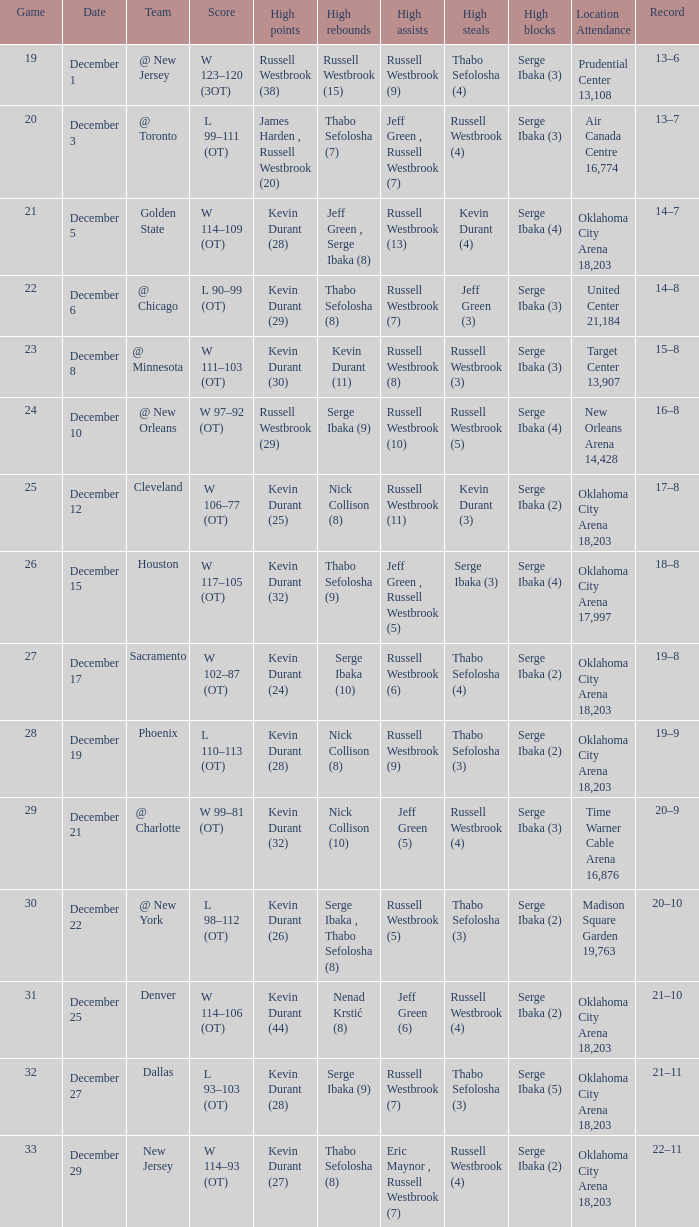On december 27, what was the record? 21–11. 